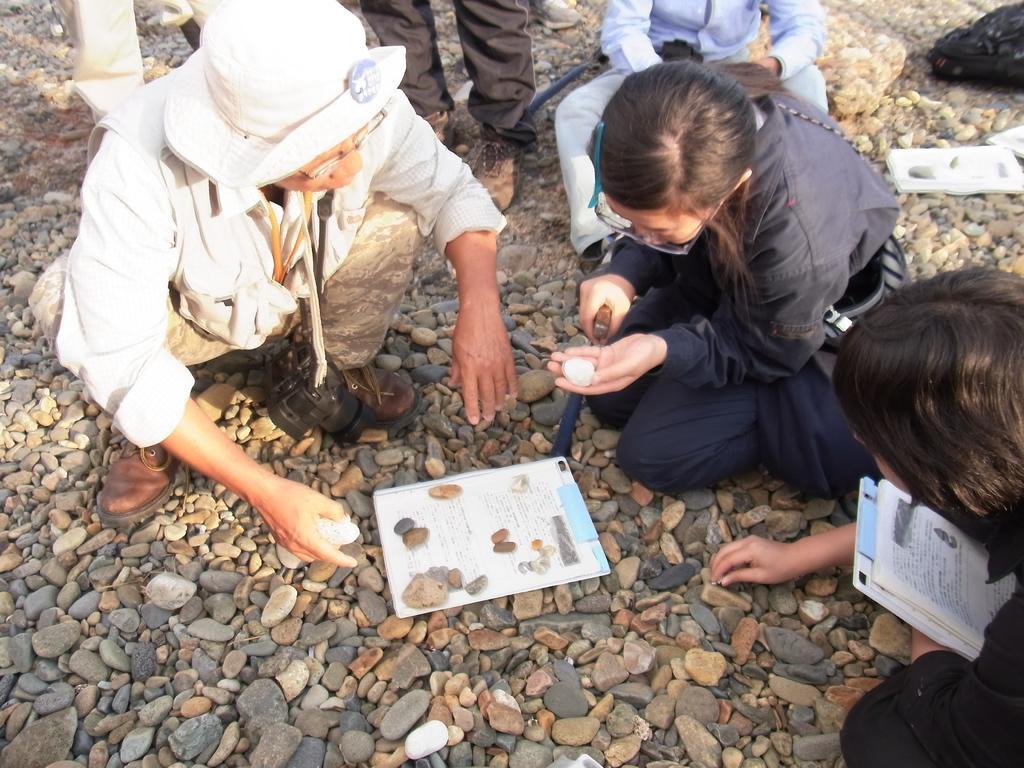Could you give a brief overview of what you see in this image? In this image we can see men and women are sitting on the land and we can see stones on the land. One woman is wearing dark blue color dress and holding stone in her hand. One woman is holding book in her hand. There is a man who is wearing white color shirt, white hat and carrying camera in his neck. On the land, one book is there. 